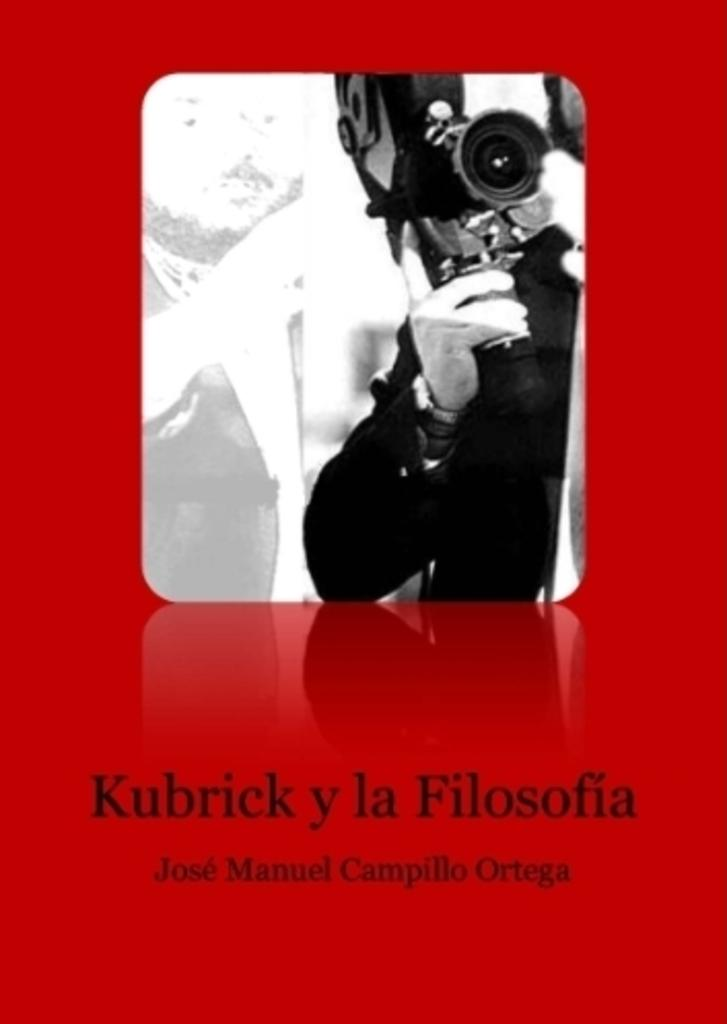What can be seen hanging on the wall in the image? There is a poster in the image. How many people are present in the image? There are two persons in the image. What is one person doing in the image? One person is holding a camera. What is written or printed at the bottom of the image? There is text at the bottom of the image. How many ladybugs are crawling on the poster in the image? There are no ladybugs present in the image. What type of goldfish can be seen swimming in the text at the bottom of the image? There are no goldfish present in the image, and the text does not contain any images or illustrations. 